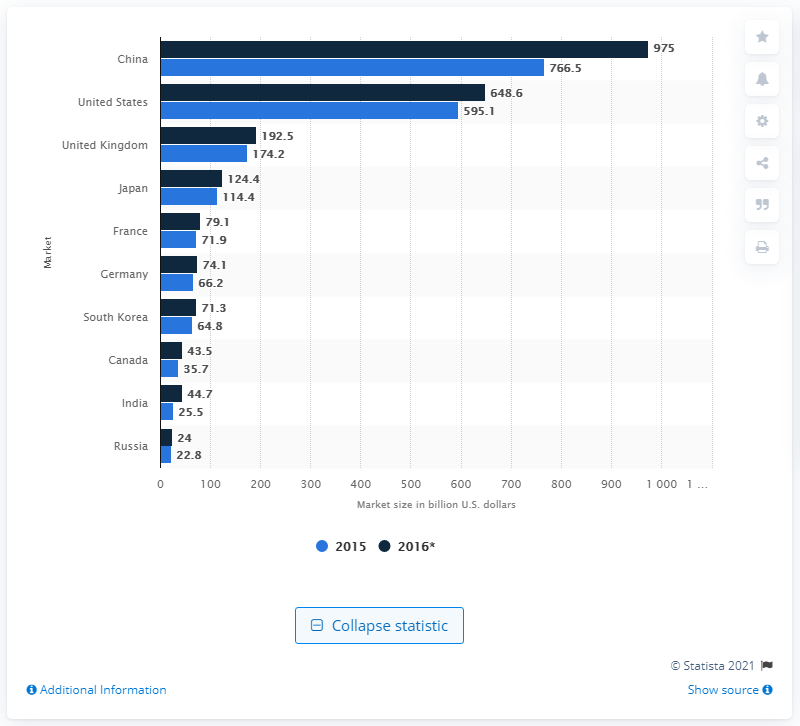Indicate a few pertinent items in this graphic. In 2015, the United States spent approximately 595.1 billion U.S. dollars on e-commerce. The estimated value of China's B2C e-commerce market was 766.5 billion. 